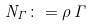<formula> <loc_0><loc_0><loc_500><loc_500>N _ { \Gamma } \colon = \rho \, \Gamma</formula> 